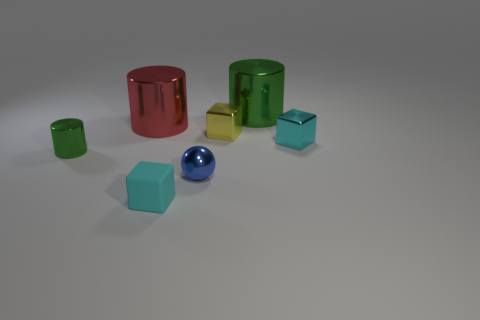There is a large cylinder on the right side of the tiny blue sphere; does it have the same color as the tiny metal cylinder?
Offer a very short reply. Yes. There is a thing that is the same color as the tiny cylinder; what is its shape?
Provide a succinct answer. Cylinder. The metallic block that is the same color as the small matte object is what size?
Ensure brevity in your answer.  Small. Are there any other things that have the same size as the yellow thing?
Offer a very short reply. Yes. What is the large cylinder left of the large thing that is to the right of the small yellow shiny block made of?
Provide a short and direct response. Metal. The metallic thing that is to the left of the tiny ball and to the right of the tiny green metallic object has what shape?
Your answer should be compact. Cylinder. The other cyan object that is the same shape as the cyan matte object is what size?
Make the answer very short. Small. Are there fewer red cylinders in front of the ball than tiny yellow blocks?
Provide a succinct answer. Yes. There is a cyan cube that is behind the small blue shiny sphere; what size is it?
Offer a very short reply. Small. What is the color of the other small metallic thing that is the same shape as the red shiny object?
Give a very brief answer. Green. 